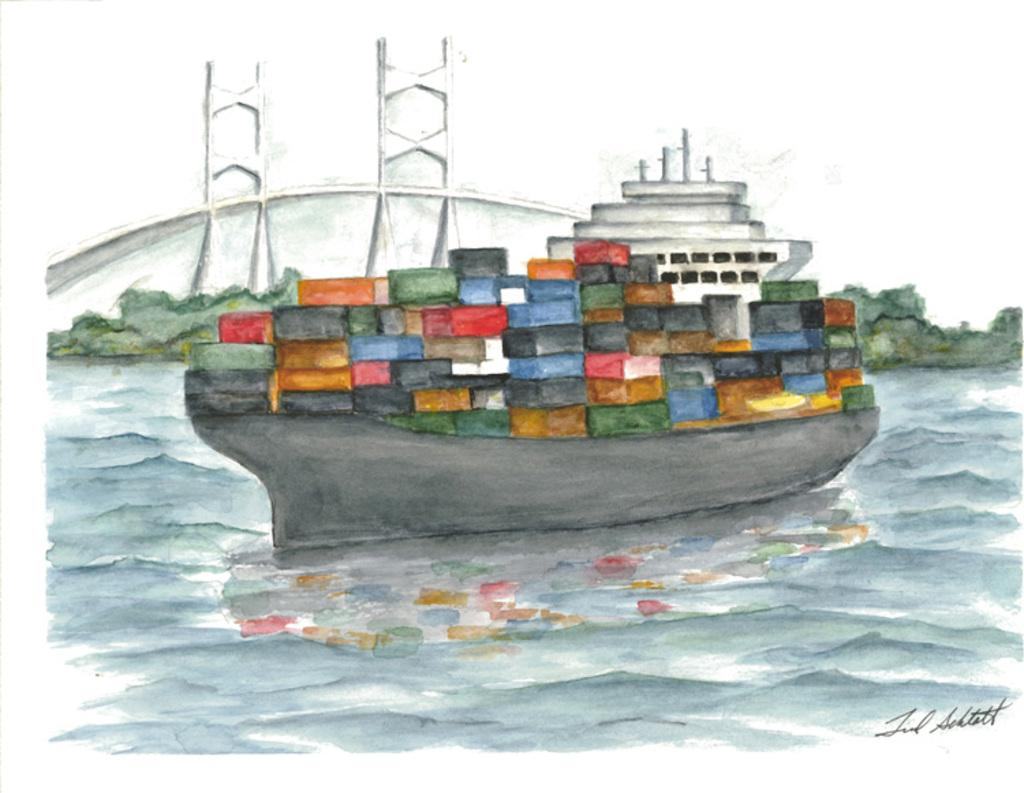What is the main subject of the painting in the image? There is a painting of a ship in the image. What type of environment is depicted in the painting? The painting depicts water and trees. Are there any structures present in the painting? Yes, there is a bridge in the painting. Where can we find text in the image? There is text written in the bottom right corner of the image. What type of toy can be seen floating in the water in the image? There is no toy present in the image; the painting depicts a ship, water, trees, and a bridge. 